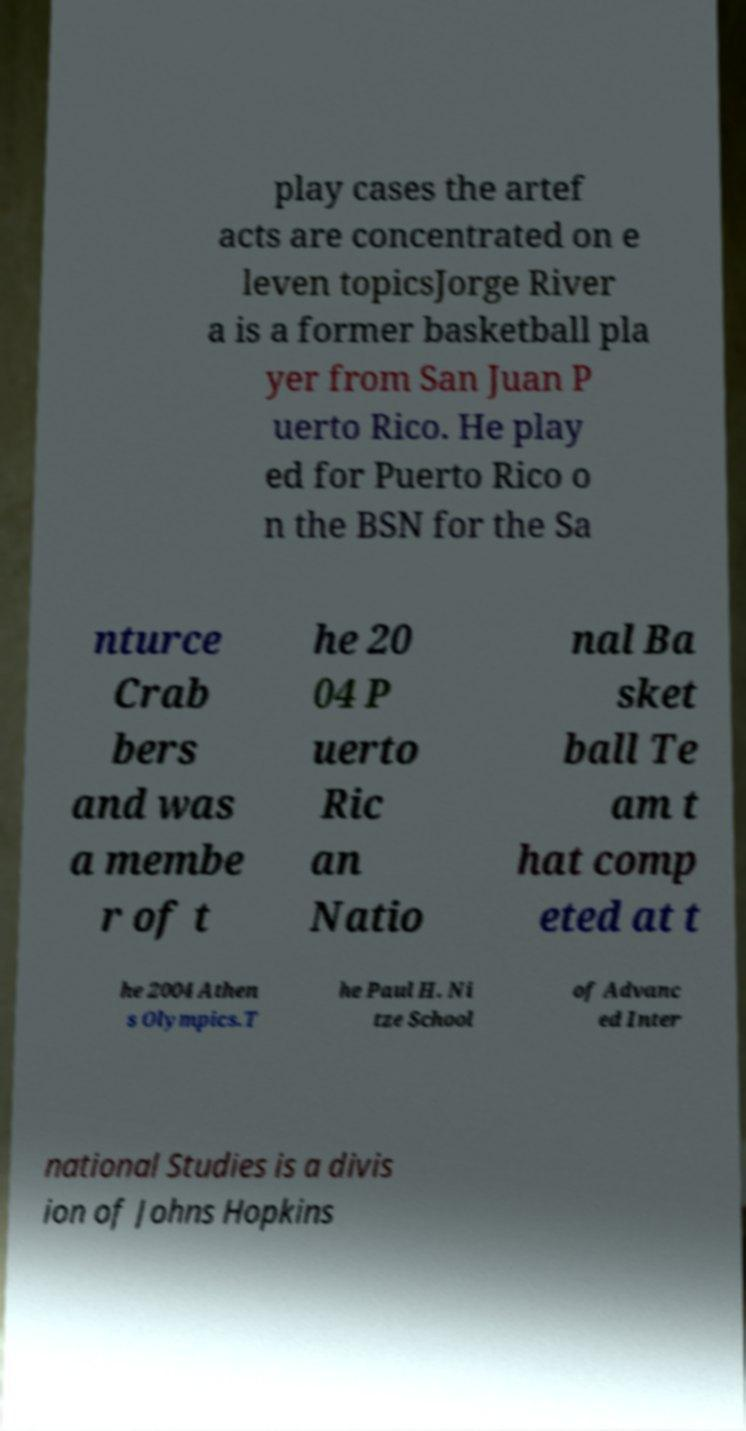Could you extract and type out the text from this image? play cases the artef acts are concentrated on e leven topicsJorge River a is a former basketball pla yer from San Juan P uerto Rico. He play ed for Puerto Rico o n the BSN for the Sa nturce Crab bers and was a membe r of t he 20 04 P uerto Ric an Natio nal Ba sket ball Te am t hat comp eted at t he 2004 Athen s Olympics.T he Paul H. Ni tze School of Advanc ed Inter national Studies is a divis ion of Johns Hopkins 